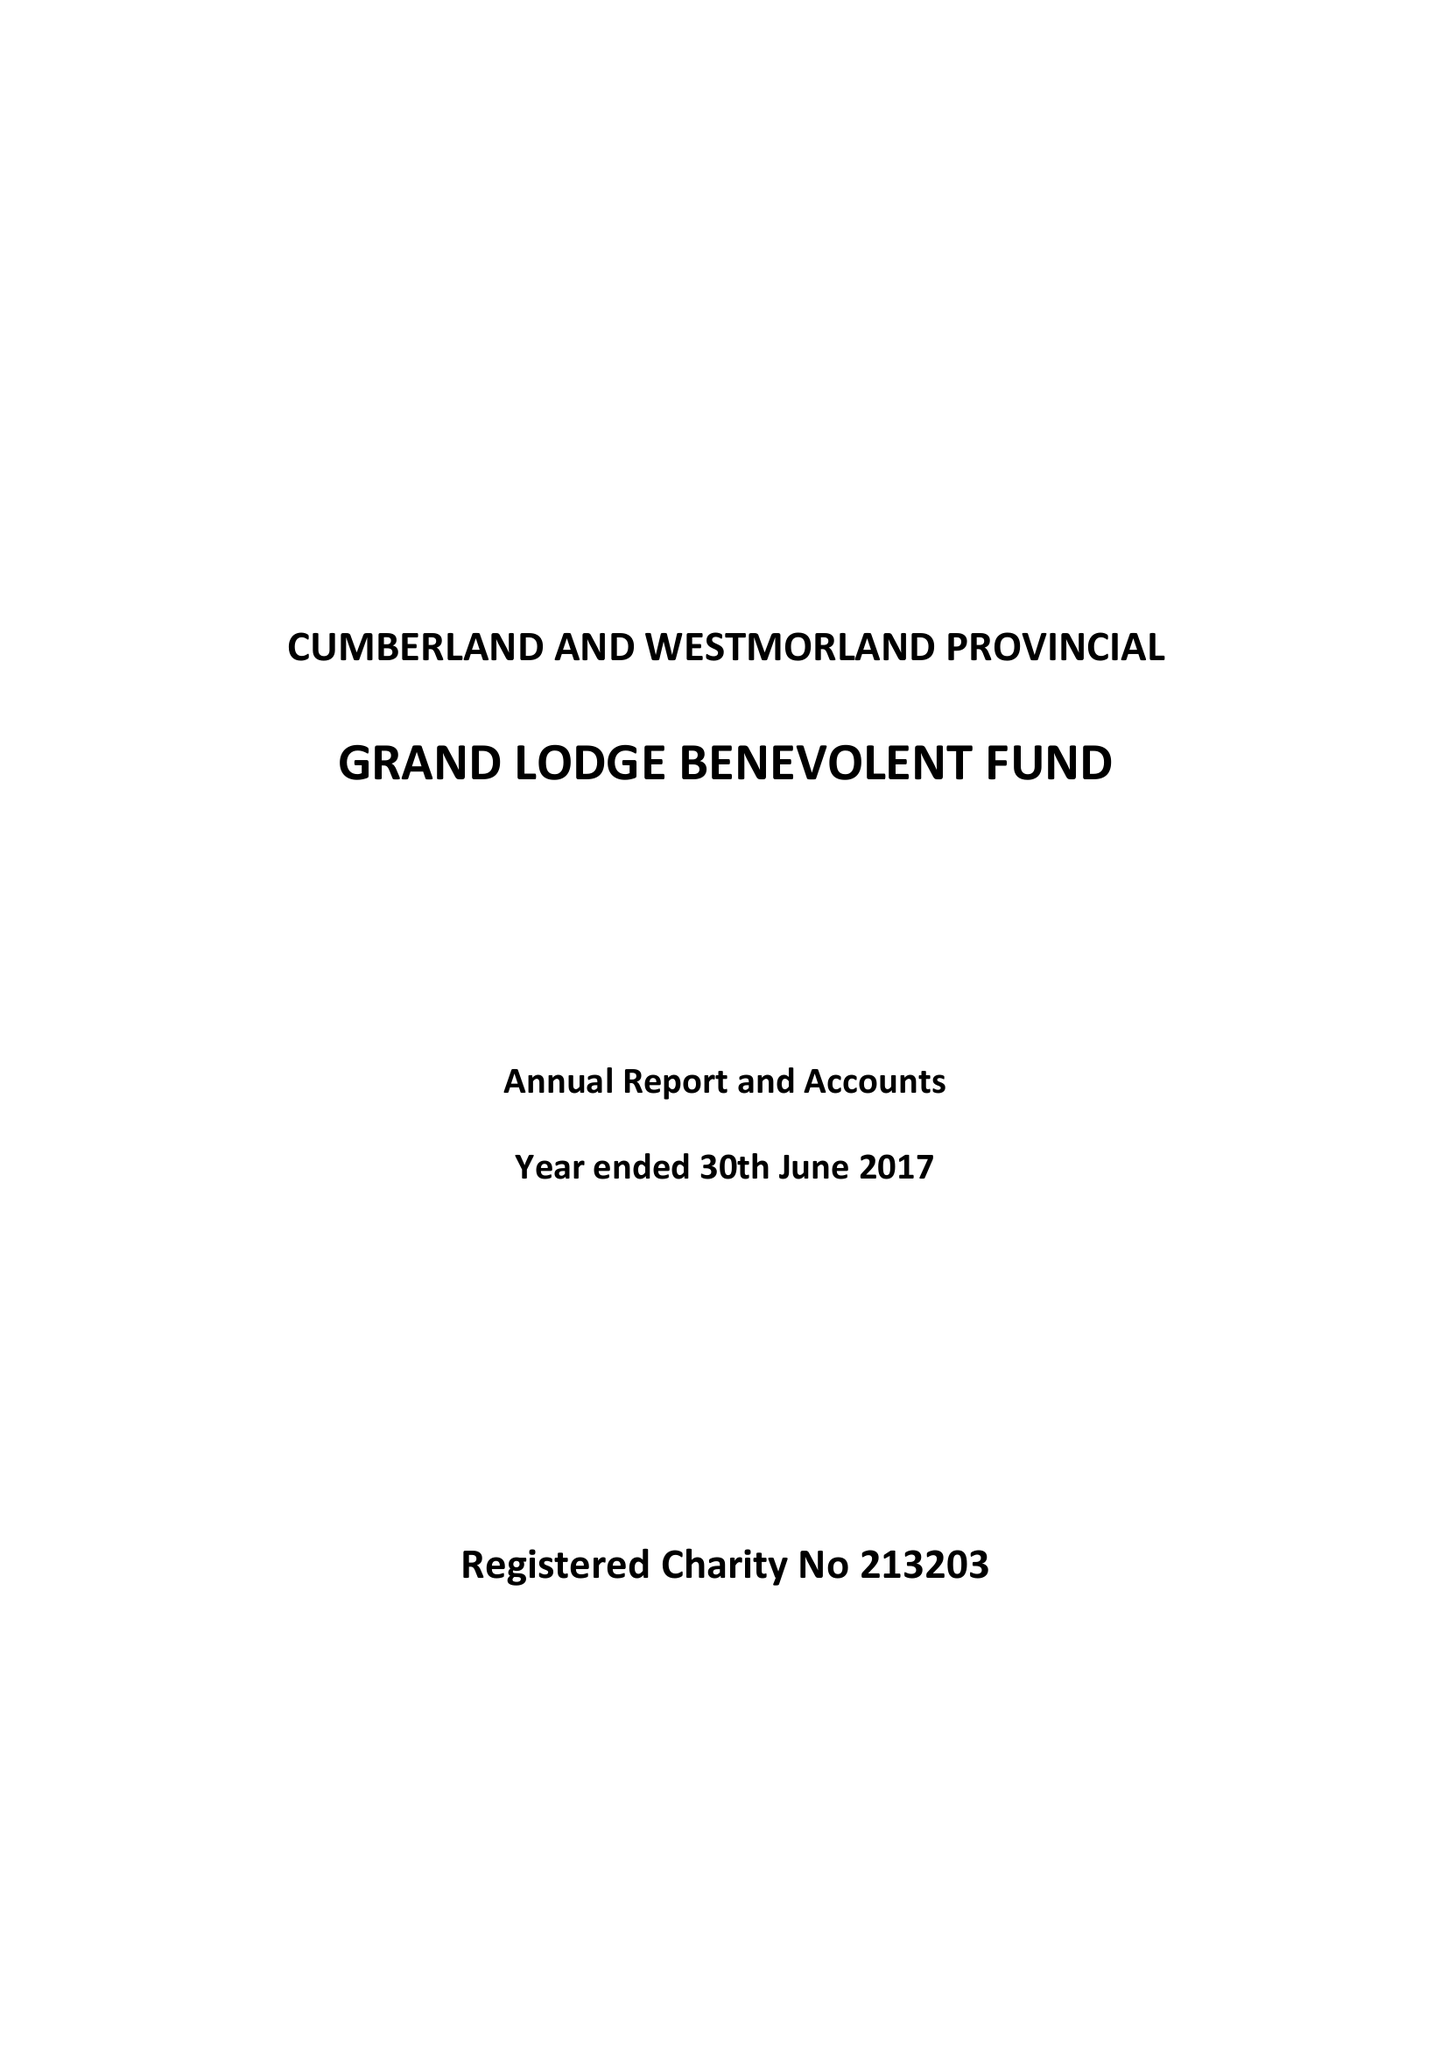What is the value for the charity_name?
Answer the question using a single word or phrase. The Cumberland and Westmorland Provincial Grand Lodge Masonic Benevolent Fund 